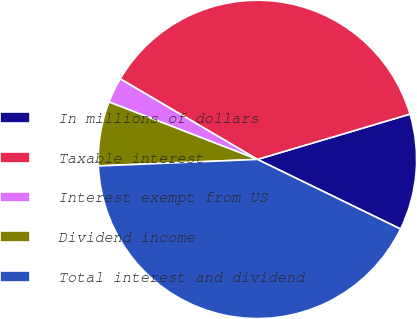Convert chart. <chart><loc_0><loc_0><loc_500><loc_500><pie_chart><fcel>In millions of dollars<fcel>Taxable interest<fcel>Interest exempt from US<fcel>Dividend income<fcel>Total interest and dividend<nl><fcel>11.8%<fcel>36.96%<fcel>2.57%<fcel>6.53%<fcel>42.14%<nl></chart> 